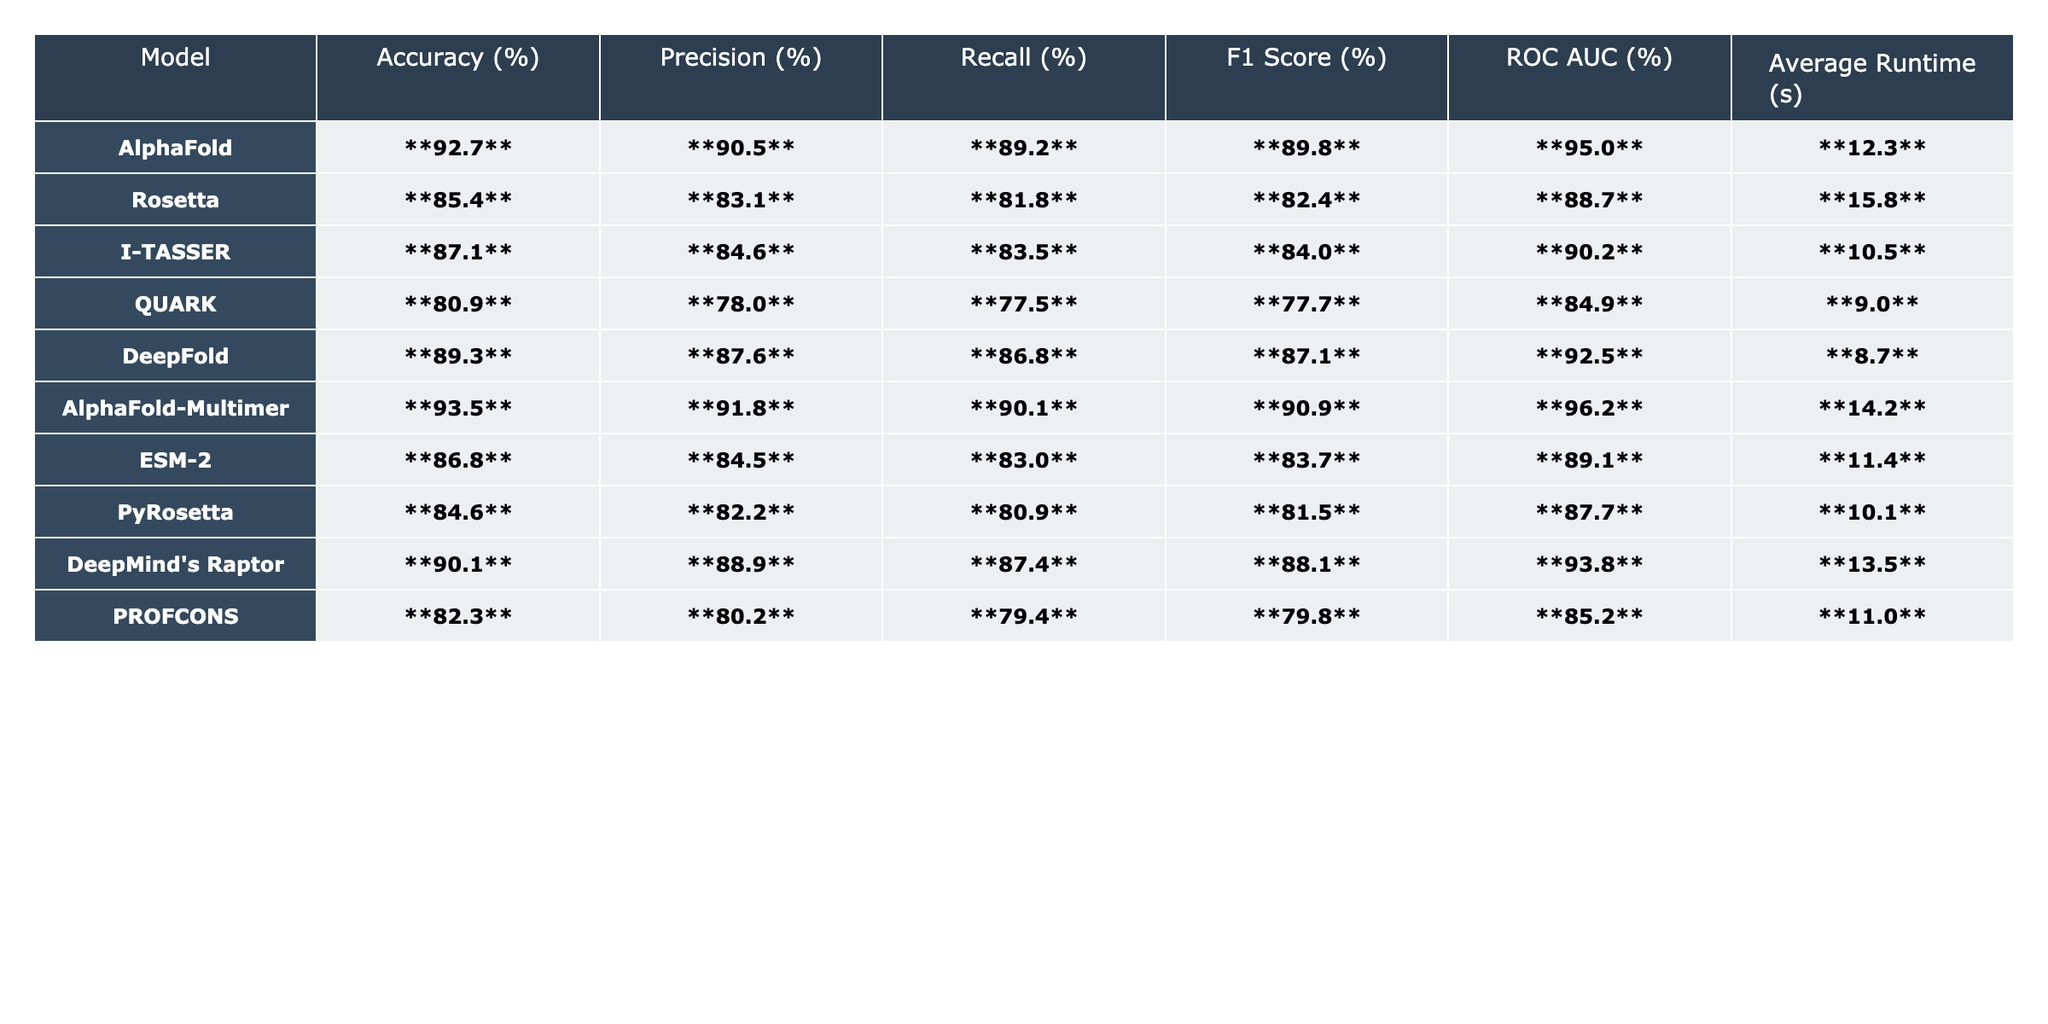What is the accuracy of AlphaFold? According to the table, the accuracy value for AlphaFold is given as **92.7%**.
Answer: 92.7% Which model has the highest F1 Score? The table shows that AlphaFold-Multimer has the highest F1 Score of **90.9%**, compared to other models.
Answer: AlphaFold-Multimer What is the average precision of the models listed? To find the average precision, sum the precision values (90.5 + 83.1 + 84.6 + 78.0 + 87.6 + 91.8 + 84.5 + 82.2 + 88.9 + 80.2) which equals 871.4. Dividing this by the number of models (10) gives us an average precision of 87.14%.
Answer: 87.14% Is the recall of DeepFold greater than that of Rosetta? DeepFold's recall is **86.8%** and Rosetta's recall is **81.8%**. Since 86.8% is greater than 81.8%, the statement is true.
Answer: Yes What is the difference in ROC AUC between AlphaFold-Multimer and QUARK? The ROC AUC for AlphaFold-Multimer is **96.2%** and for QUARK it is **84.9%**. The difference is calculated as 96.2 - 84.9 = 11.3%.
Answer: 11.3% Which model has the longest average runtime? Comparing the average runtimes, Rosetta has the longest at **15.8 seconds**.
Answer: Rosetta Are the accuracy and F1 Score of I-TASSER greater than 85%? I-TASSER's accuracy is **87.1%** and its F1 Score is **84.0%**. Since the F1 Score is not greater than 85%, the statement is false.
Answer: No If we consider the top three models based on accuracy, what is their average runtime? The three models with the highest accuracy are AlphaFold-Multimer (14.2s), AlphaFold (12.3s), and DeepFold (8.7s). Summing the runtimes gives 14.2 + 12.3 + 8.7 = 35.2. Dividing by 3 gives an average runtime of 11.73 seconds.
Answer: 11.73 Which model has the second highest ROC AUC value? The second highest ROC AUC in the table is from DeepMind's Raptor with **93.8%**, while AlphaFold-Multimer is the highest.
Answer: DeepMind's Raptor Is there a model that achieves an F1 Score above 85 without exceeding an accuracy of 90%? Both I-TASSER (accuracy 87.1%, F1 Score 84.0%) and DeepFold (accuracy 89.3%, F1 Score 87.1%) meet this criterion, as they both have F1 Scores above 85 but accuracy below 90.
Answer: Yes 